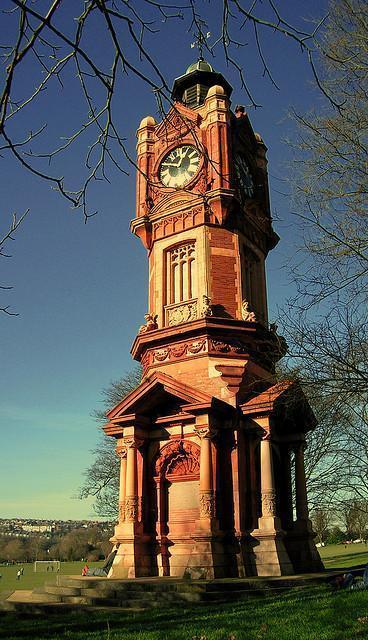How many clock faces does this building have?
Give a very brief answer. 2. 